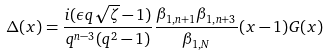Convert formula to latex. <formula><loc_0><loc_0><loc_500><loc_500>\Delta ( x ) = \frac { i ( \epsilon q \sqrt { \zeta } - 1 ) } { q ^ { n - 3 } ( q ^ { 2 } - 1 ) } \frac { \beta _ { 1 , n + 1 } \beta _ { 1 , n + 3 } } { \beta _ { 1 , N } } ( x - 1 ) G ( x )</formula> 